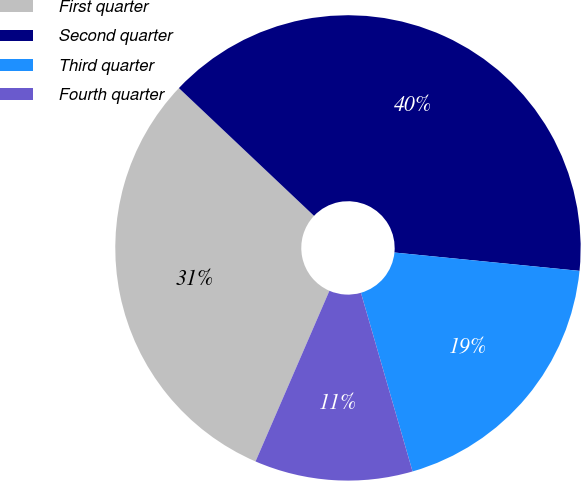Convert chart to OTSL. <chart><loc_0><loc_0><loc_500><loc_500><pie_chart><fcel>First quarter<fcel>Second quarter<fcel>Third quarter<fcel>Fourth quarter<nl><fcel>30.55%<fcel>39.52%<fcel>18.95%<fcel>10.98%<nl></chart> 